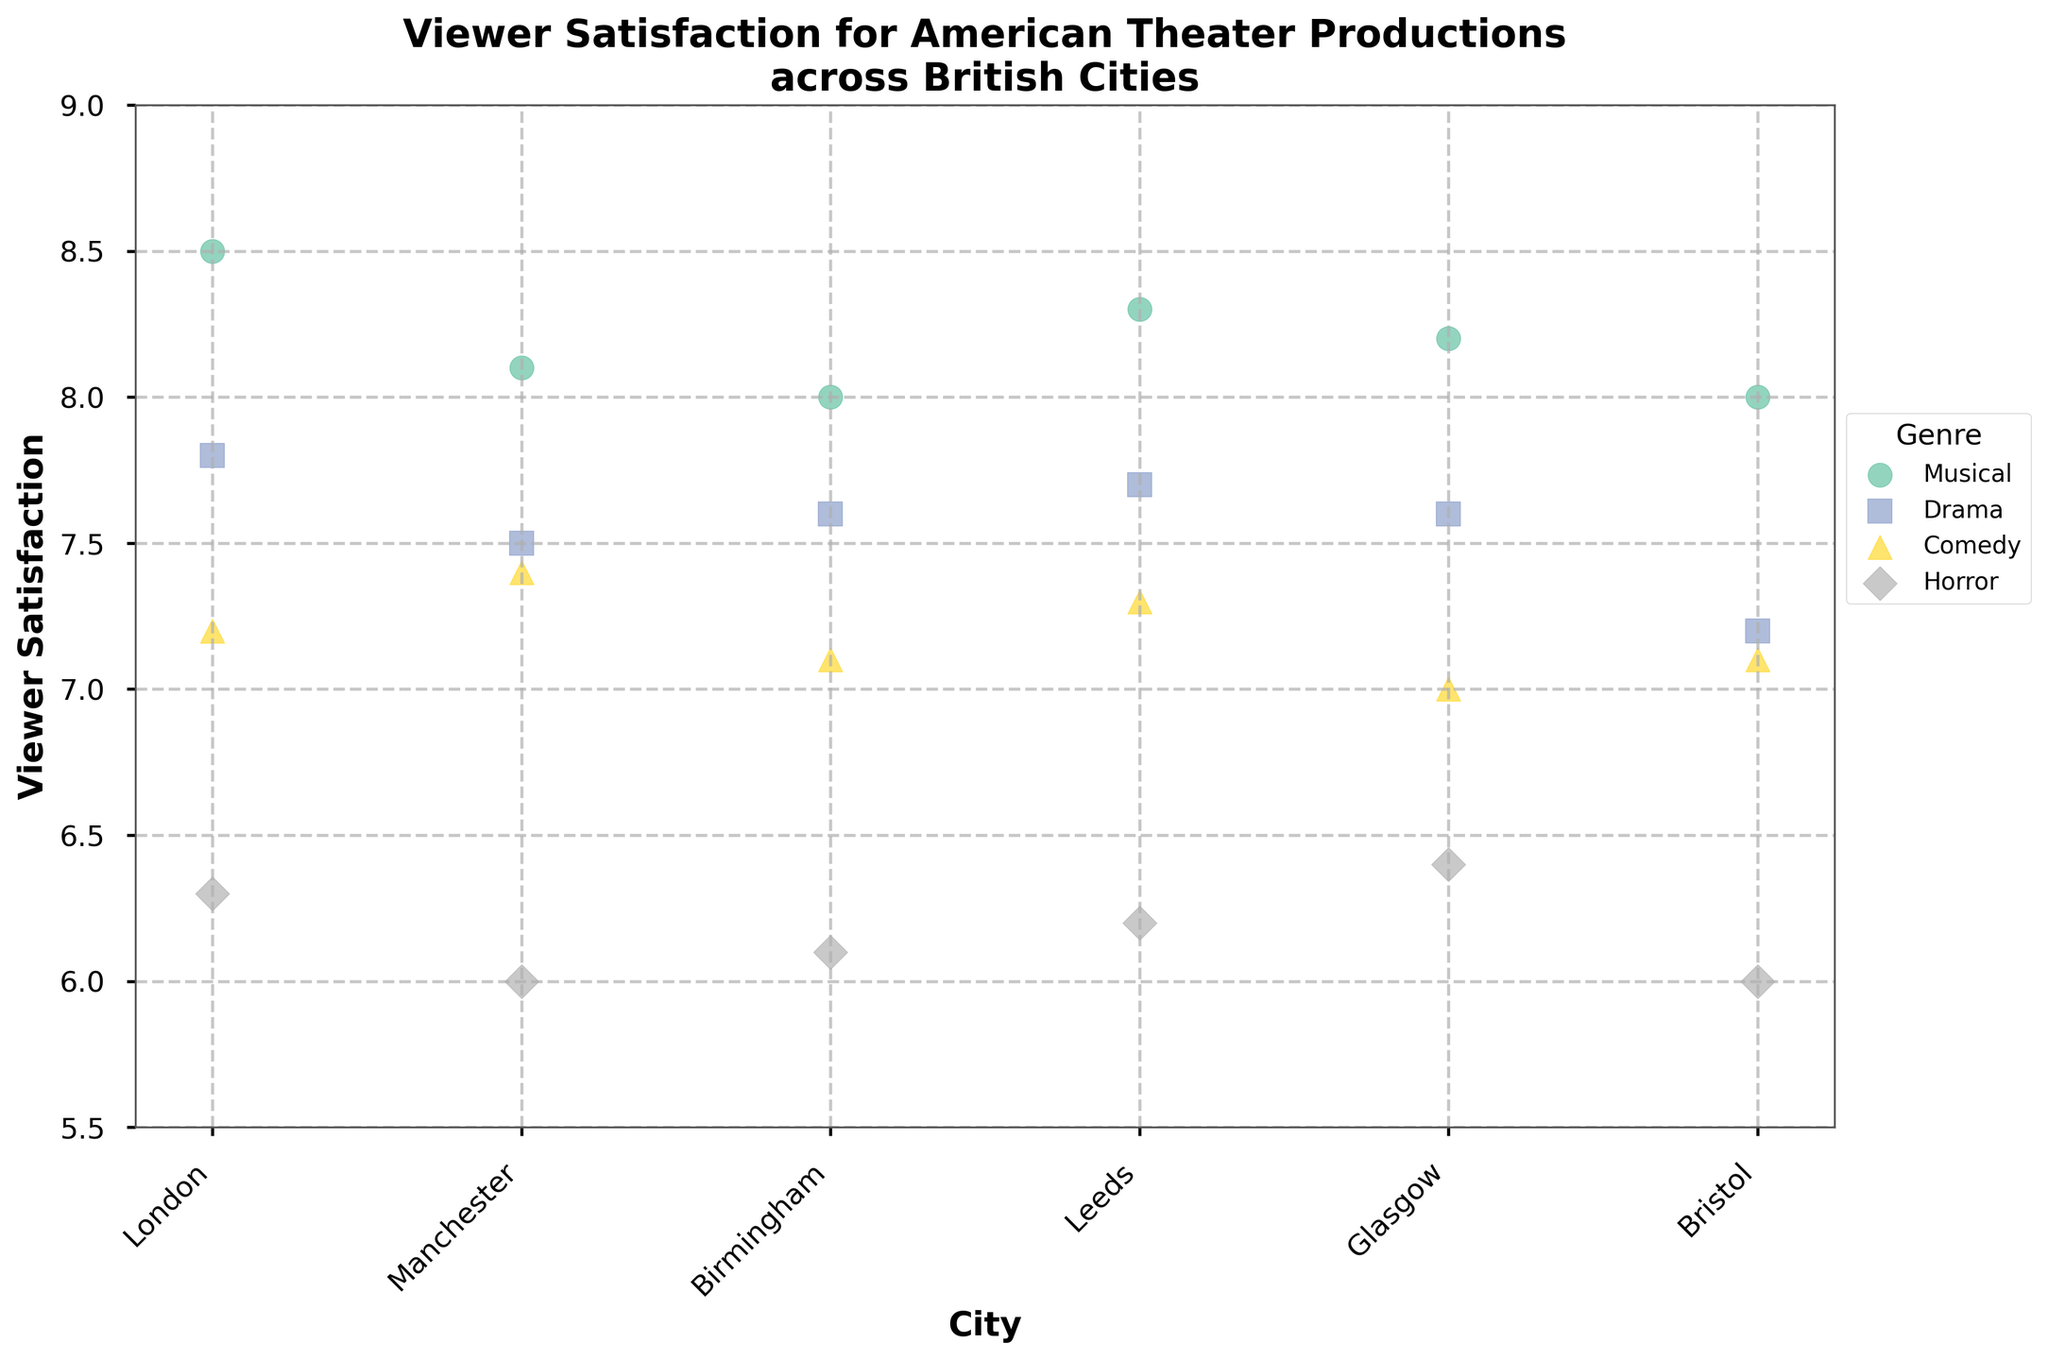What is the title of the figure? The title can be found at the top of the figure. It provides an overview of what the plot is illustrating. The title is "Viewer Satisfaction for American Theater Productions across British Cities."
Answer: "Viewer Satisfaction for American Theater Productions across British Cities" Which City has the highest Viewer Satisfaction for Musicals? To answer this, look at the scatter points for Musicals across different cities and identify the highest value on the Viewer Satisfaction axis. London has the highest value at 8.5.
Answer: London What is the average Viewer Satisfaction for Horror genre across all cities? Calculate the average by summing the Viewer Satisfaction values for Horror genre (6.3, 6.0, 6.1, 6.2, 6.4, 6.0) and dividing by the number of cities (6). The sum is 37.0, and the average is 37.0 / 6 = 6.17.
Answer: 6.17 How does Viewer Satisfaction for Dramas in Manchester compare to that in Glasgow? Compare the values for Dramas in Manchester (7.5) and Glasgow (7.6). Glasgow's Viewer Satisfaction for Dramas is slightly higher.
Answer: Glasgow is higher Which genre has the most consistent Viewer Satisfaction across all cities? Consistency can be observed by looking for the genre with the least variation in Viewer Satisfaction across cities. The Musical genre appears most consistent, with values ranging between 8.0 and 8.5.
Answer: Musical Is there any city where Comedy has higher Viewer Satisfaction than Drama? Compare Comedy and Drama values for each city. In Manchester, Comedy has a value of 7.4, which is higher than Drama’s 7.5. In all other cities, Drama has a higher satisfaction. Therefore, Comedy in Manchester has a higher satisfaction compared to Drama.
Answer: No What is the difference in Viewer Satisfaction for Musicals between the city with the highest and lowest satisfaction? Identify the highest Viewer Satisfaction for Musicals (London, 8.5) and the lowest (Birmingham & Bristol, 8.0). The difference is 8.5 - 8.0 = 0.5.
Answer: 0.5 